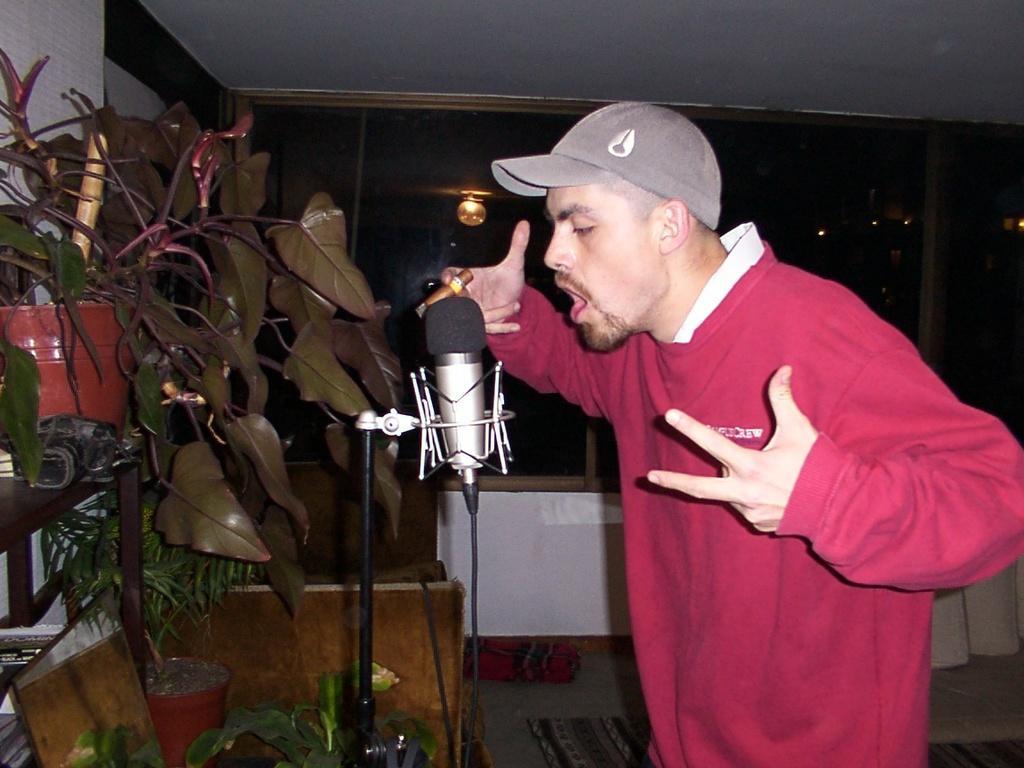Describe this image in one or two sentences. In this image we can see a person. A person is speaking into a microphone. There are few house plants in the image. There is a lamp in the image. There are few objects at the right side of the image. 